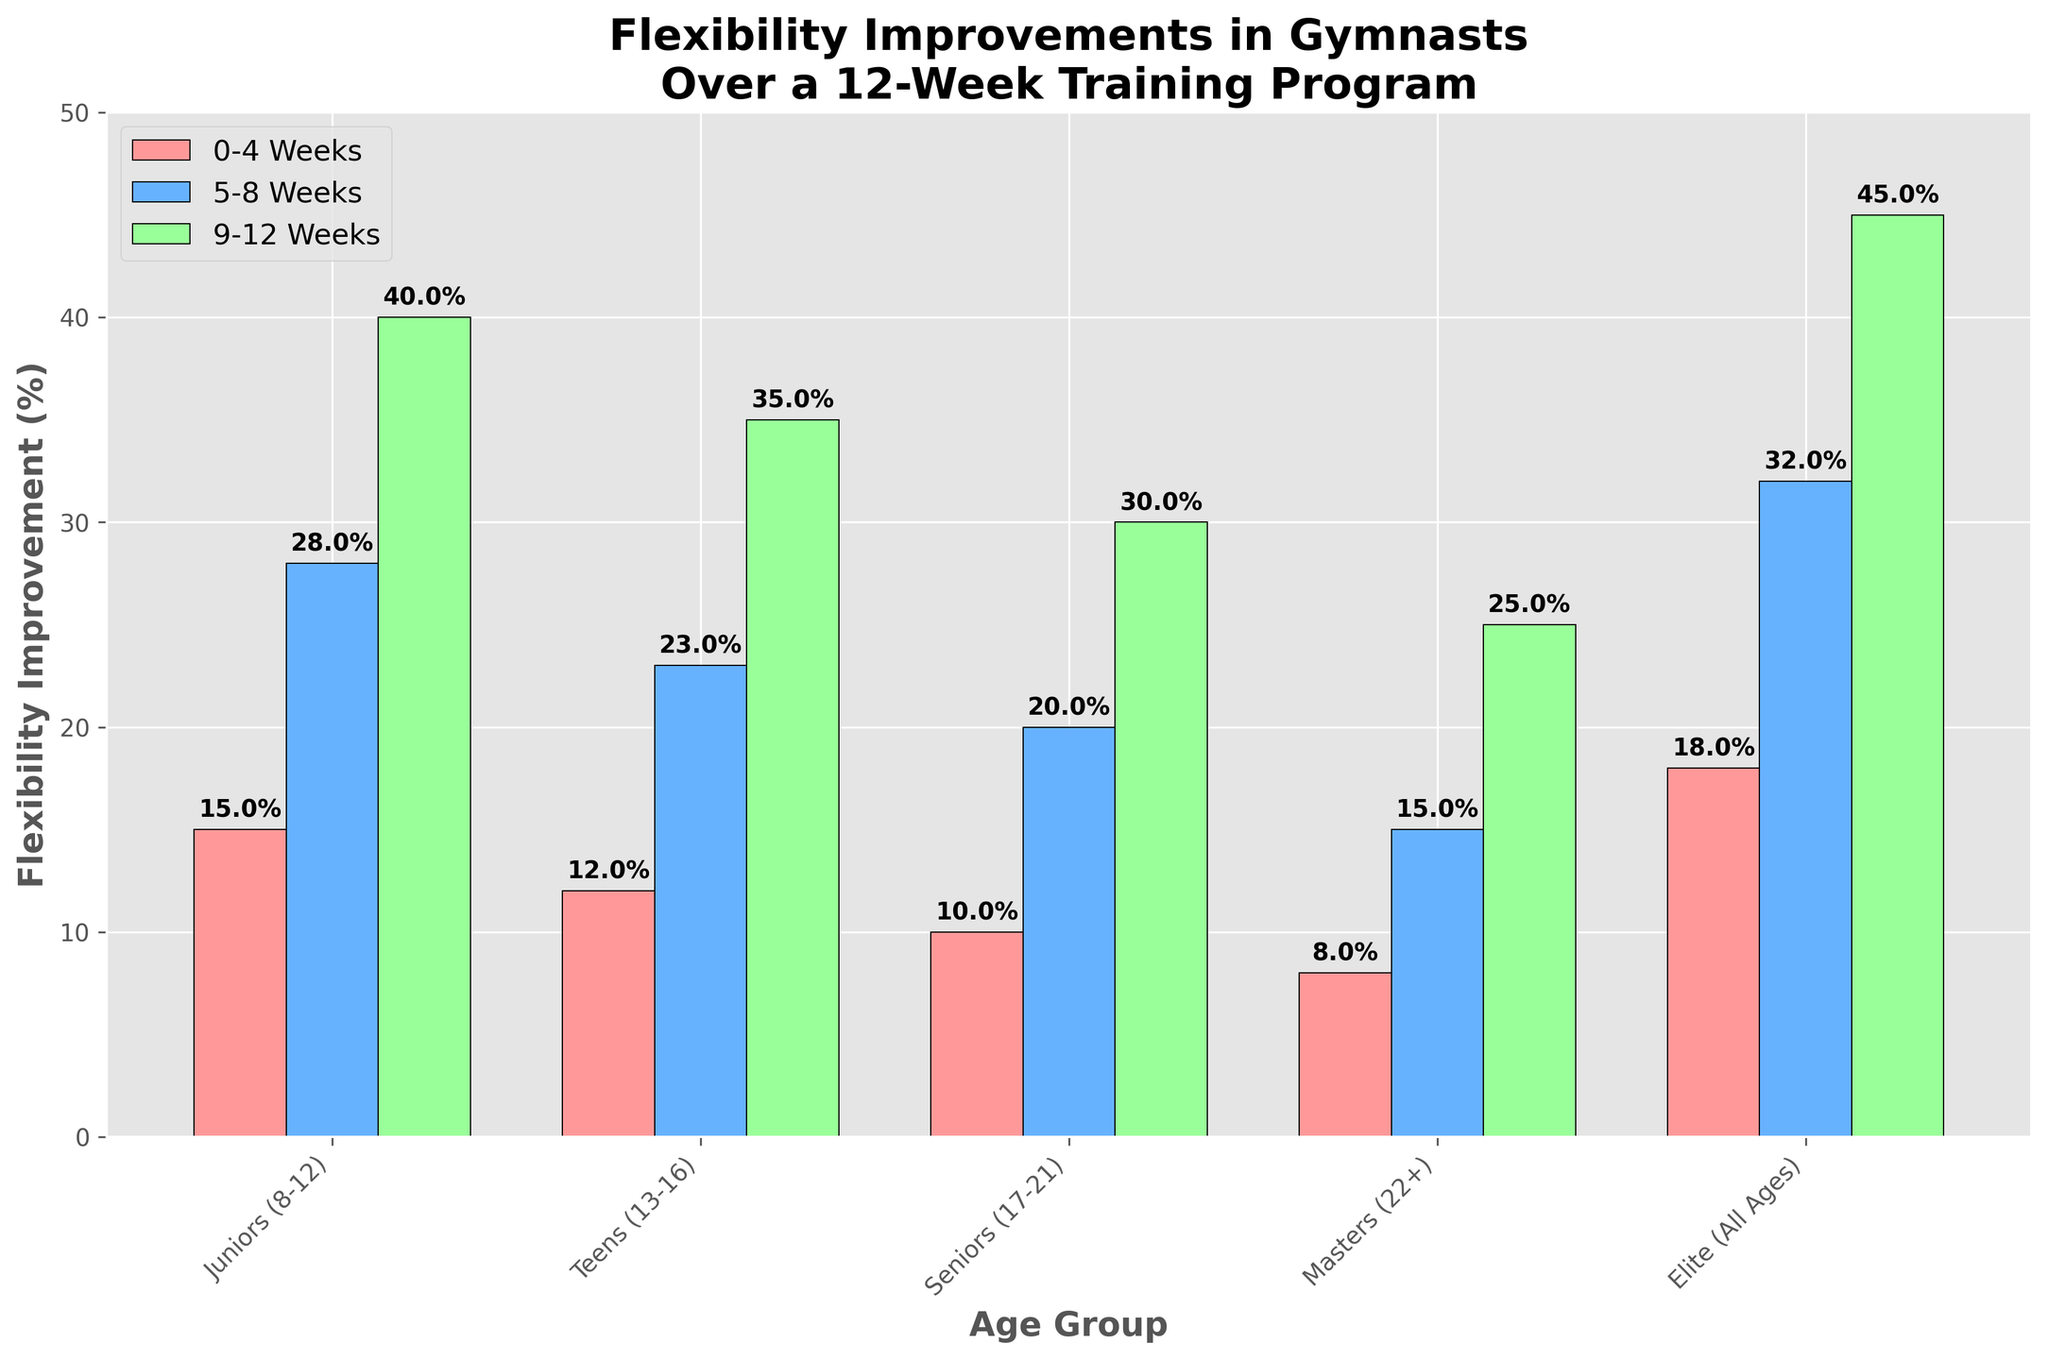Which age group showed the greatest flexibility improvement at 0-4 weeks? Look at the bars for the 0-4 weeks period and compare their heights. The 'Elite (All Ages)' group shows the highest improvement.
Answer: Elite (All Ages) How much did flexibility improve for the Masters (22+) group between 0-4 weeks and 9-12 weeks? Subtract the 0-4 weeks value (8%) from the 9-12 weeks value (25%). Calculation: 25% - 8% = 17%.
Answer: 17% Which two age groups have the closest flexibility improvement percentage at 5-8 weeks? Compare the heights of the bars in the 5-8 weeks period for all groups. The closest heights are for the Teens (13-16) and Seniors (17-21) groups.
Answer: Teens (13-16) and Seniors (17-21) What is the average flexibility improvement for the Elite group over the 12 weeks? Add the percentage improvements for the Elite group at 0-4 weeks (18%), 5-8 weeks (32%), and 9-12 weeks (45%), then divide by 3. Calculation: (18% + 32% + 45%) / 3 = 31.67%.
Answer: 31.67% Which age group showed the least improvement at 9-12 weeks, and by how much was it lower than the highest improvement? Look at the bars for 9-12 weeks and identify the smallest and largest values. The least improvement is for the Masters (22%) at 25%, and the highest is for the Elite (All Ages) at 45%. Calculate the difference: 45% - 25% = 20%.
Answer: Masters (22+), 20% Is the flexibility improvement percentage for Seniors (17-21) at 5-8 weeks higher or lower than that of Juniors (8-12) at 0-4 weeks, and by how much? Compare the heights of the 5-8 weeks bar for Seniors (20%) and the 0-4 weeks bar for Juniors (15%). Calculate the difference: 20% - 15% = 5%. The percentage for Seniors (17-21) at 5-8 weeks is higher.
Answer: Higher, 5% Which age group had the most significant improvement between 5-8 weeks and 9-12 weeks? Compare the differences in values between 5-8 weeks and 9-12 weeks for all groups. The Elite group shows the largest increase from 32% to 45%.
Answer: Elite (All Ages) How much higher is the flexibility improvement for the Juniors (8-12) group at 9-12 weeks compared to their improvement at 0-4 weeks? Calculate the difference between the percentages at 9-12 weeks (40%) and 0-4 weeks (15%) for the Juniors. Calculation: 40% - 15% = 25%.
Answer: 25% 